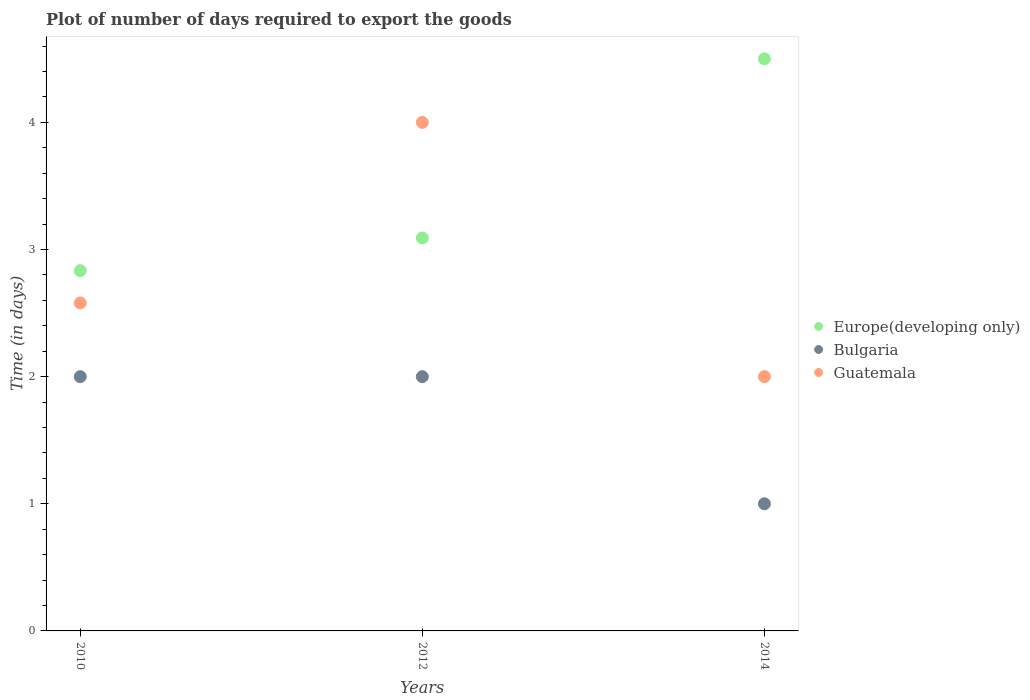What is the time required to export goods in Bulgaria in 2010?
Keep it short and to the point. 2. Across all years, what is the maximum time required to export goods in Bulgaria?
Your answer should be very brief. 2. Across all years, what is the minimum time required to export goods in Bulgaria?
Keep it short and to the point. 1. What is the total time required to export goods in Europe(developing only) in the graph?
Keep it short and to the point. 10.43. What is the difference between the time required to export goods in Bulgaria in 2010 and that in 2014?
Your response must be concise. 1. What is the average time required to export goods in Guatemala per year?
Make the answer very short. 2.86. In the year 2012, what is the difference between the time required to export goods in Europe(developing only) and time required to export goods in Bulgaria?
Make the answer very short. 1.09. In how many years, is the time required to export goods in Guatemala greater than 3.6 days?
Provide a succinct answer. 1. What is the ratio of the time required to export goods in Europe(developing only) in 2010 to that in 2014?
Offer a very short reply. 0.63. Is the difference between the time required to export goods in Europe(developing only) in 2010 and 2014 greater than the difference between the time required to export goods in Bulgaria in 2010 and 2014?
Provide a short and direct response. No. What is the difference between the highest and the second highest time required to export goods in Guatemala?
Ensure brevity in your answer.  1.42. What is the difference between the highest and the lowest time required to export goods in Guatemala?
Offer a terse response. 2. In how many years, is the time required to export goods in Europe(developing only) greater than the average time required to export goods in Europe(developing only) taken over all years?
Your response must be concise. 1. Is it the case that in every year, the sum of the time required to export goods in Guatemala and time required to export goods in Europe(developing only)  is greater than the time required to export goods in Bulgaria?
Your answer should be very brief. Yes. Does the time required to export goods in Guatemala monotonically increase over the years?
Provide a succinct answer. No. Is the time required to export goods in Europe(developing only) strictly greater than the time required to export goods in Bulgaria over the years?
Your answer should be compact. Yes. How many dotlines are there?
Offer a terse response. 3. What is the difference between two consecutive major ticks on the Y-axis?
Offer a very short reply. 1. Are the values on the major ticks of Y-axis written in scientific E-notation?
Offer a terse response. No. Does the graph contain any zero values?
Make the answer very short. No. Does the graph contain grids?
Your answer should be very brief. No. What is the title of the graph?
Ensure brevity in your answer.  Plot of number of days required to export the goods. What is the label or title of the X-axis?
Give a very brief answer. Years. What is the label or title of the Y-axis?
Offer a very short reply. Time (in days). What is the Time (in days) of Europe(developing only) in 2010?
Provide a short and direct response. 2.83. What is the Time (in days) of Guatemala in 2010?
Your answer should be compact. 2.58. What is the Time (in days) of Europe(developing only) in 2012?
Ensure brevity in your answer.  3.09. Across all years, what is the maximum Time (in days) of Bulgaria?
Provide a succinct answer. 2. Across all years, what is the minimum Time (in days) of Europe(developing only)?
Ensure brevity in your answer.  2.83. Across all years, what is the minimum Time (in days) in Bulgaria?
Give a very brief answer. 1. Across all years, what is the minimum Time (in days) of Guatemala?
Your answer should be compact. 2. What is the total Time (in days) of Europe(developing only) in the graph?
Keep it short and to the point. 10.43. What is the total Time (in days) in Guatemala in the graph?
Give a very brief answer. 8.58. What is the difference between the Time (in days) in Europe(developing only) in 2010 and that in 2012?
Offer a very short reply. -0.26. What is the difference between the Time (in days) in Bulgaria in 2010 and that in 2012?
Provide a succinct answer. 0. What is the difference between the Time (in days) of Guatemala in 2010 and that in 2012?
Ensure brevity in your answer.  -1.42. What is the difference between the Time (in days) of Europe(developing only) in 2010 and that in 2014?
Offer a terse response. -1.67. What is the difference between the Time (in days) of Guatemala in 2010 and that in 2014?
Ensure brevity in your answer.  0.58. What is the difference between the Time (in days) of Europe(developing only) in 2012 and that in 2014?
Your answer should be compact. -1.41. What is the difference between the Time (in days) in Guatemala in 2012 and that in 2014?
Make the answer very short. 2. What is the difference between the Time (in days) of Europe(developing only) in 2010 and the Time (in days) of Bulgaria in 2012?
Offer a terse response. 0.83. What is the difference between the Time (in days) of Europe(developing only) in 2010 and the Time (in days) of Guatemala in 2012?
Offer a terse response. -1.17. What is the difference between the Time (in days) in Bulgaria in 2010 and the Time (in days) in Guatemala in 2012?
Give a very brief answer. -2. What is the difference between the Time (in days) of Europe(developing only) in 2010 and the Time (in days) of Bulgaria in 2014?
Offer a very short reply. 1.83. What is the difference between the Time (in days) of Europe(developing only) in 2010 and the Time (in days) of Guatemala in 2014?
Provide a short and direct response. 0.83. What is the difference between the Time (in days) in Europe(developing only) in 2012 and the Time (in days) in Bulgaria in 2014?
Your answer should be very brief. 2.09. What is the average Time (in days) in Europe(developing only) per year?
Provide a short and direct response. 3.48. What is the average Time (in days) in Guatemala per year?
Your answer should be very brief. 2.86. In the year 2010, what is the difference between the Time (in days) of Europe(developing only) and Time (in days) of Bulgaria?
Keep it short and to the point. 0.83. In the year 2010, what is the difference between the Time (in days) of Europe(developing only) and Time (in days) of Guatemala?
Offer a very short reply. 0.25. In the year 2010, what is the difference between the Time (in days) in Bulgaria and Time (in days) in Guatemala?
Offer a very short reply. -0.58. In the year 2012, what is the difference between the Time (in days) in Europe(developing only) and Time (in days) in Guatemala?
Offer a terse response. -0.91. In the year 2012, what is the difference between the Time (in days) of Bulgaria and Time (in days) of Guatemala?
Make the answer very short. -2. In the year 2014, what is the difference between the Time (in days) in Europe(developing only) and Time (in days) in Guatemala?
Your answer should be compact. 2.5. What is the ratio of the Time (in days) in Europe(developing only) in 2010 to that in 2012?
Provide a short and direct response. 0.92. What is the ratio of the Time (in days) in Guatemala in 2010 to that in 2012?
Offer a very short reply. 0.65. What is the ratio of the Time (in days) of Europe(developing only) in 2010 to that in 2014?
Your answer should be compact. 0.63. What is the ratio of the Time (in days) in Bulgaria in 2010 to that in 2014?
Make the answer very short. 2. What is the ratio of the Time (in days) in Guatemala in 2010 to that in 2014?
Offer a terse response. 1.29. What is the ratio of the Time (in days) of Europe(developing only) in 2012 to that in 2014?
Provide a short and direct response. 0.69. What is the ratio of the Time (in days) of Bulgaria in 2012 to that in 2014?
Provide a succinct answer. 2. What is the difference between the highest and the second highest Time (in days) of Europe(developing only)?
Offer a very short reply. 1.41. What is the difference between the highest and the second highest Time (in days) of Guatemala?
Offer a terse response. 1.42. What is the difference between the highest and the lowest Time (in days) of Europe(developing only)?
Your answer should be very brief. 1.67. 